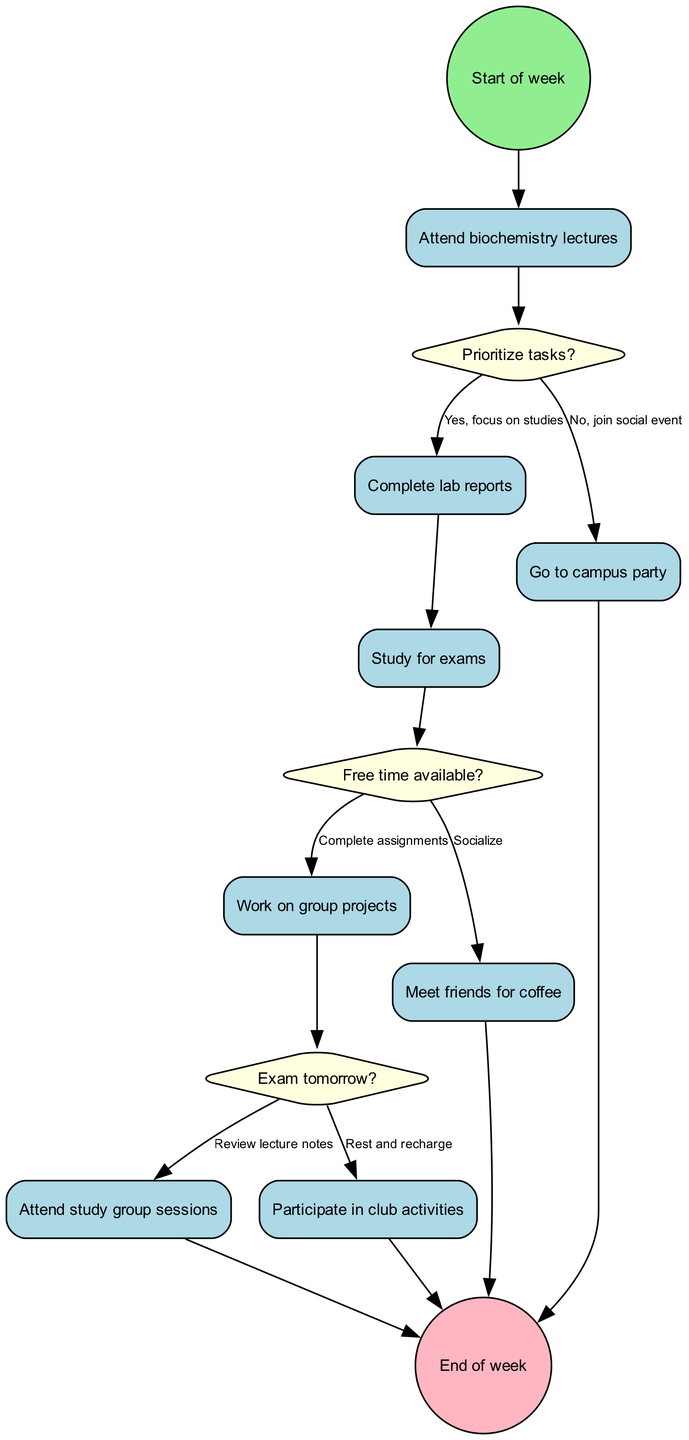What is the initial node of the diagram? The initial node is labeled "Start of week," indicating the beginning point of the activities being analyzed in this weekly schedule.
Answer: Start of week How many activities are listed in the diagram? There are a total of eight activities depicted, each representing a specific task or event to be completed during the week.
Answer: 8 What is the final node in the diagram? The final node is marked as "End of week," which signifies the conclusion of all activities and decisions made throughout the week.
Answer: End of week Which decision node follows “Complete lab reports”? The decision node that follows "Complete lab reports" is "Exam tomorrow?", indicating that further actions depend on whether there is an upcoming exam.
Answer: Exam tomorrow? If the answer to "Free time available?" is yes, what is the next activity? If the answer is yes, the next activity is "Socialize," demonstrating that in the absence of academic responsibilities, the individual would engage in social activities.
Answer: Socialize What happens if you answer "No" to the "Prioritize tasks?" decision? If you answer "No" to "Prioritize tasks?", you proceed to a social activity, specifically "Go to campus party," indicating a shift from academics to socializing.
Answer: Go to campus party How many decision nodes are present in the diagram? There are three decision nodes present, which guide the flow of activities based on specific conditions or choices made by the individual.
Answer: 3 What do you do after “Study for exams” if the answer to "Free time available?" is no? If the answer is no to "Free time available?", the next action after "Study for exams" is to "Work on group projects," demonstrating a continuation of academic tasks.
Answer: Work on group projects 